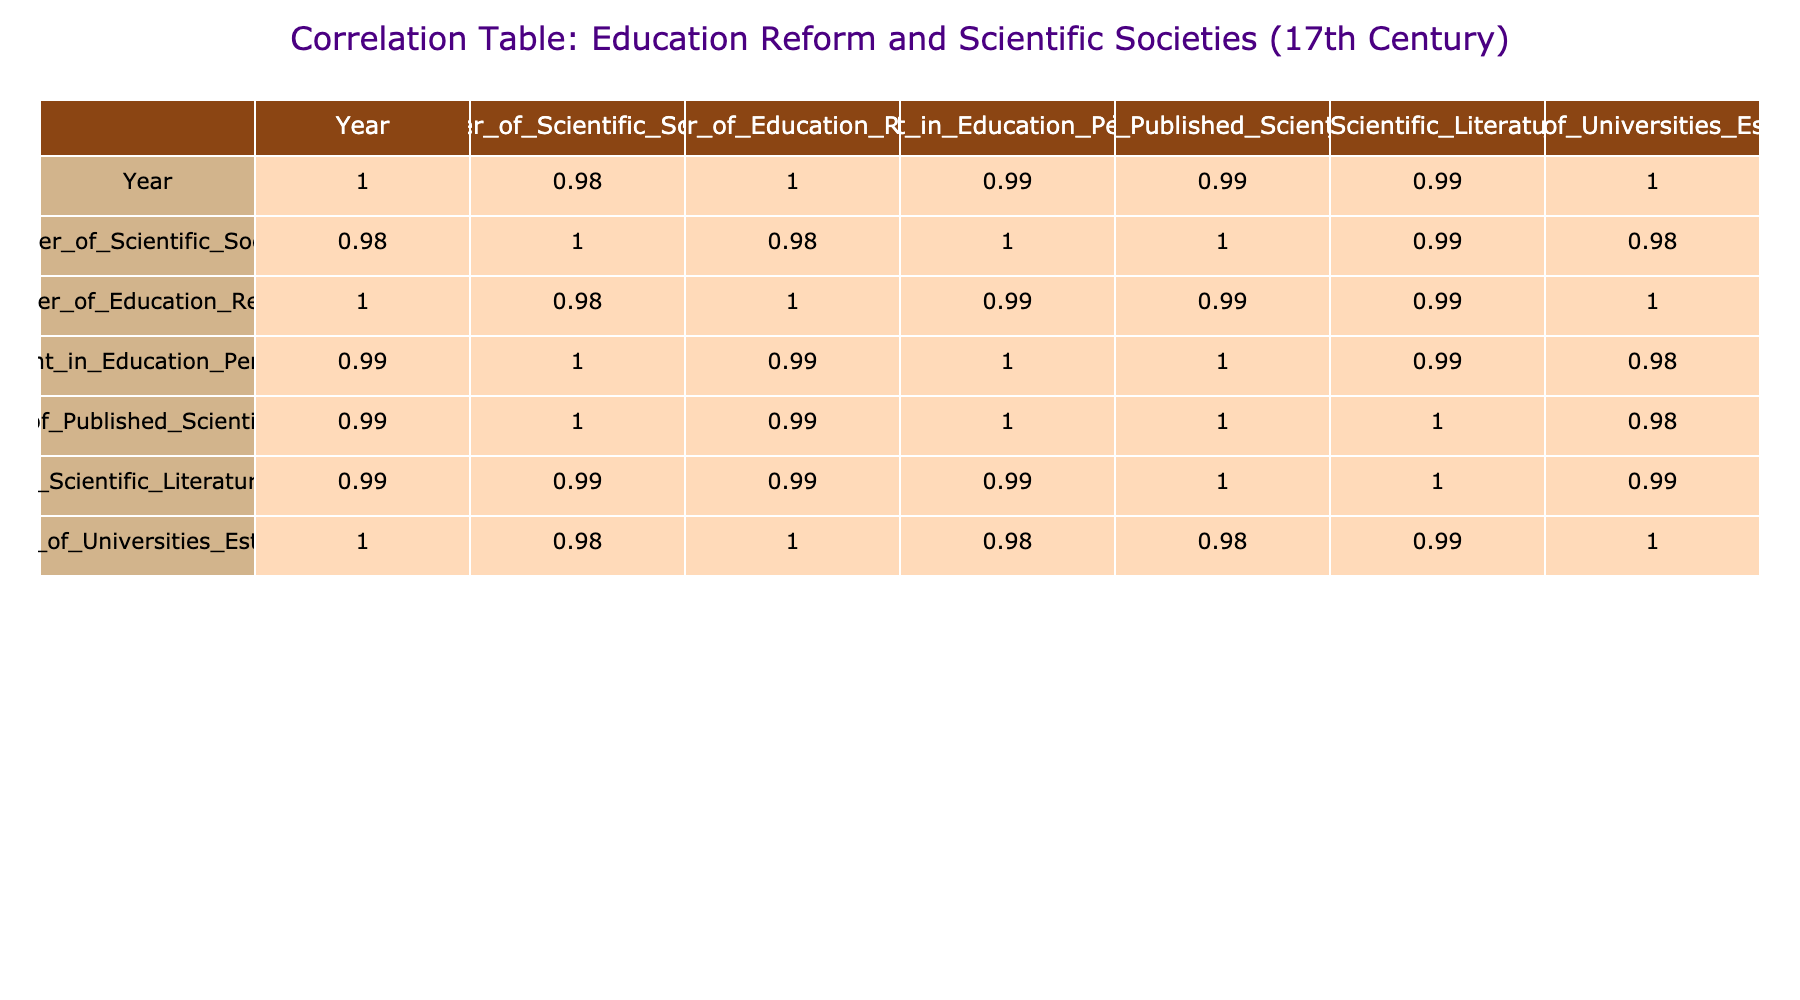What is the number of scientific societies established in 1670? The table shows the row corresponding to the year 1670, where the column "Number_of_Scientific_Societies" indicates a value of 25.
Answer: 25 What was the percentage of GDP invested in education in 1640? Referring to the row for the year 1640, the column "Investment_in_Education_Percent_GDP" indicates a value of 1.2.
Answer: 1.2 How many universities were established between 1600 and 1680? To find the total number of universities established in that time span, we sum the values for all corresponding years: 10 + 12 + 15 + 18 + 20 + 22 + 25 + 30 = 132.
Answer: 132 Did the number of published scientific papers increase every decade from 1600 to 1680? By examining the table, we see that the number of published scientific papers increased continuously from 12 in 1600 to 150 in 1680, so the answer is yes.
Answer: Yes What is the average investment in education as a percent of GDP from 1600 to 1680? We total the investment percentages across the years: 0.5 + 0.6 + 0.8 + 1.0 + 1.2 + 1.5 + 1.8 + 2.0 + 2.5 = 12.0. Dividing by the number of years (9) gives an average of 12.0 / 9 = 1.33.
Answer: 1.33 What is the correlation between the number of education reforms and the number of universities established? Looking at the correlation table, we find the corresponding value for these two variables, which is 0.97, indicating a strong positive correlation.
Answer: 0.97 What was the increase in the number of scientific societies from 1660 to 1680? The number of scientific societies in 1660 was 20, and in 1680 it was 30. The difference between these two years is 30 - 20 = 10.
Answer: 10 Is it true that the number of published scientific papers reached over 100 by 1670? Checking the table, we see the values for the years leading up to 1670, and find that the number in 1670 was 120, which confirms this fact as true.
Answer: True 